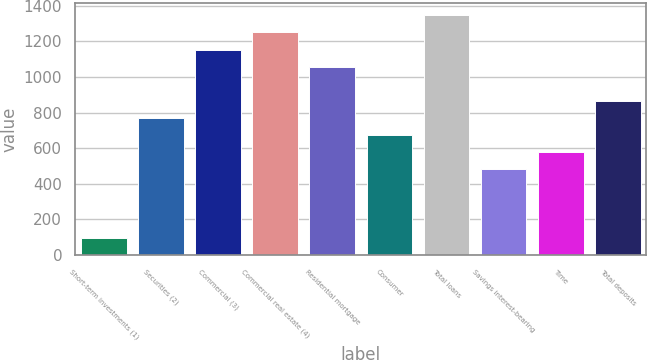Convert chart. <chart><loc_0><loc_0><loc_500><loc_500><bar_chart><fcel>Short-term investments (1)<fcel>Securities (2)<fcel>Commercial (3)<fcel>Commercial real estate (4)<fcel>Residential mortgage<fcel>Consumer<fcel>Total loans<fcel>Savings interest-bearing<fcel>Time<fcel>Total deposits<nl><fcel>98.05<fcel>770.4<fcel>1154.6<fcel>1250.65<fcel>1058.55<fcel>674.35<fcel>1346.7<fcel>482.25<fcel>578.3<fcel>866.45<nl></chart> 